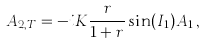Convert formula to latex. <formula><loc_0><loc_0><loc_500><loc_500>A _ { 2 , T } = - i K \frac { r } { 1 + r } \sin ( I _ { 1 } ) A _ { 1 } \, ,</formula> 